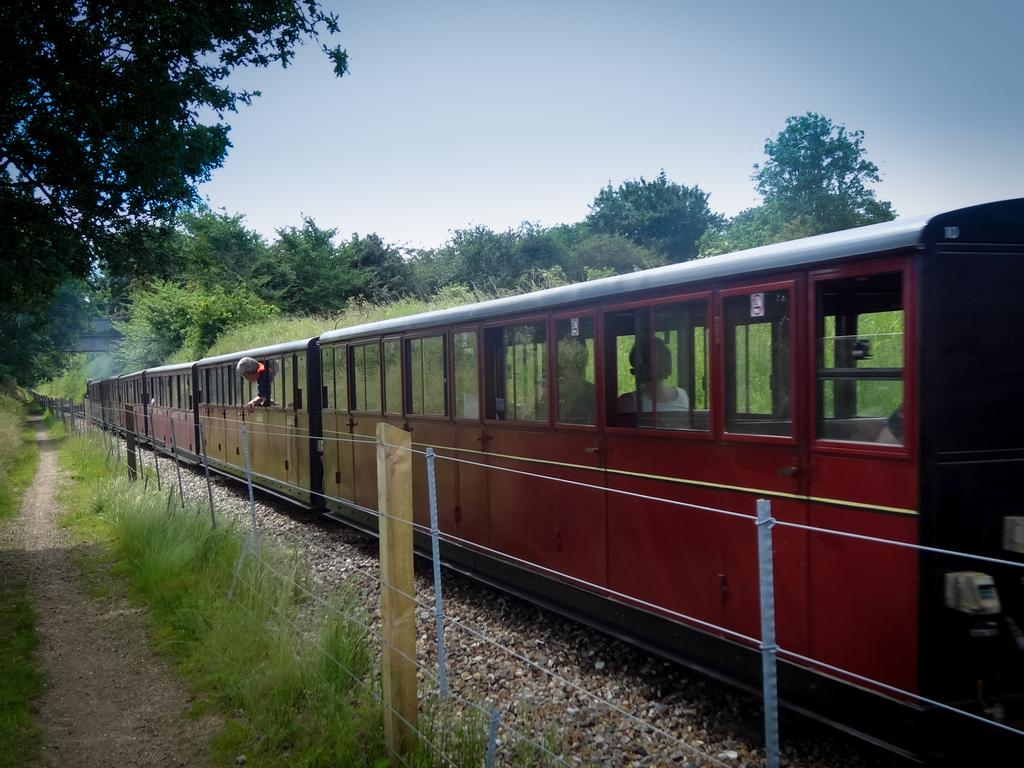What is the main subject in the center of the image? There is a train in the center of the image. What can be seen surrounding the train? There is fencing in the image. What type of natural environment is visible in the background? There are trees in the background of the image. What type of ground is visible at the bottom of the image? There is grass at the bottom of the image. Can you see a laborer working on the train in the image? There is no laborer present in the image, nor is there any indication of work being done on the train. What type of holiday is being celebrated in the image? There is no indication of a holiday being celebrated in the image. Is there a crown visible on the train in the image? There is no crown present in the image. 